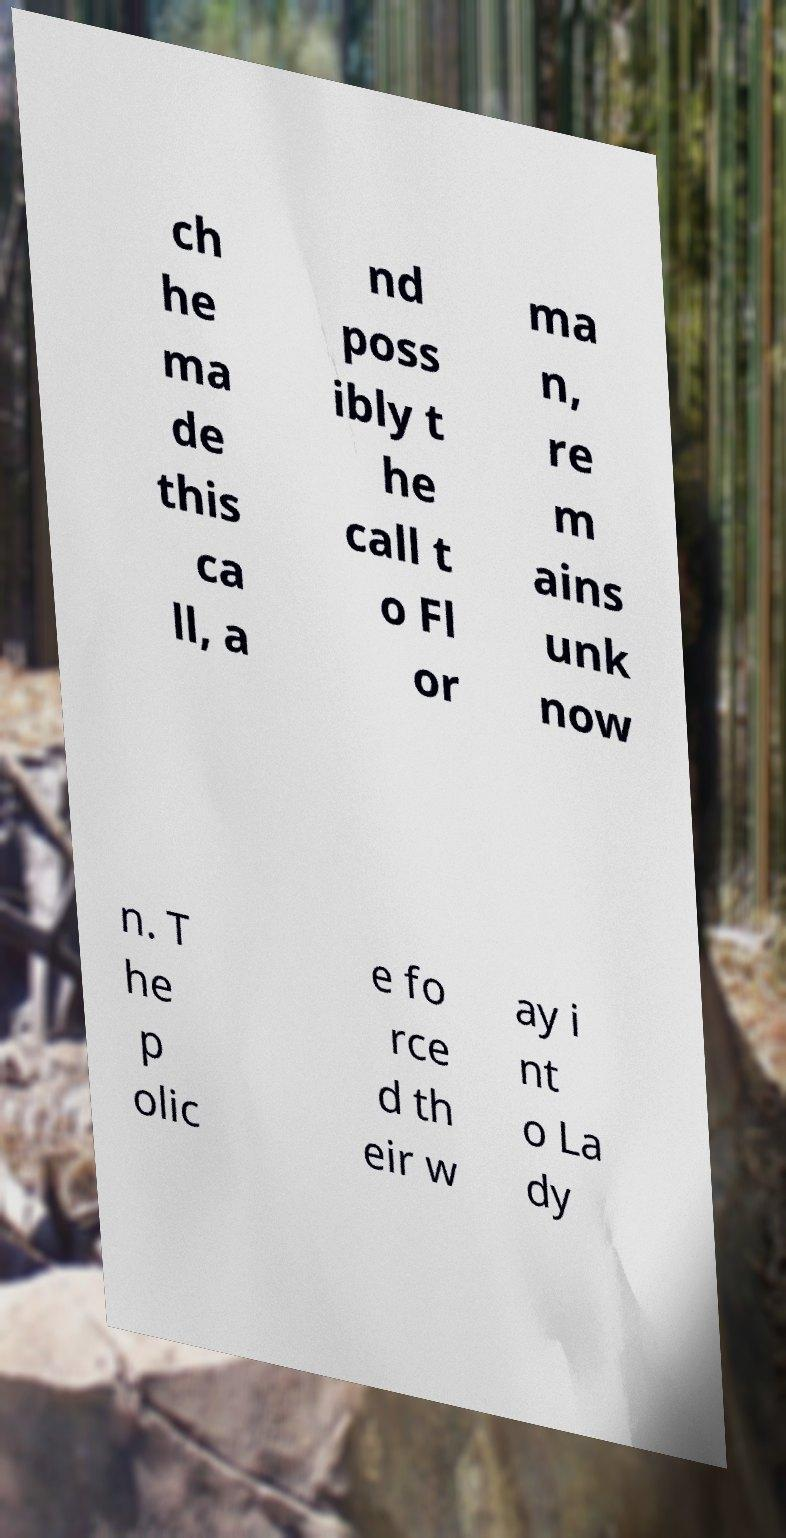What messages or text are displayed in this image? I need them in a readable, typed format. ch he ma de this ca ll, a nd poss ibly t he call t o Fl or ma n, re m ains unk now n. T he p olic e fo rce d th eir w ay i nt o La dy 